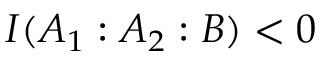Convert formula to latex. <formula><loc_0><loc_0><loc_500><loc_500>I ( A _ { 1 } \colon A _ { 2 } \colon B ) < 0</formula> 